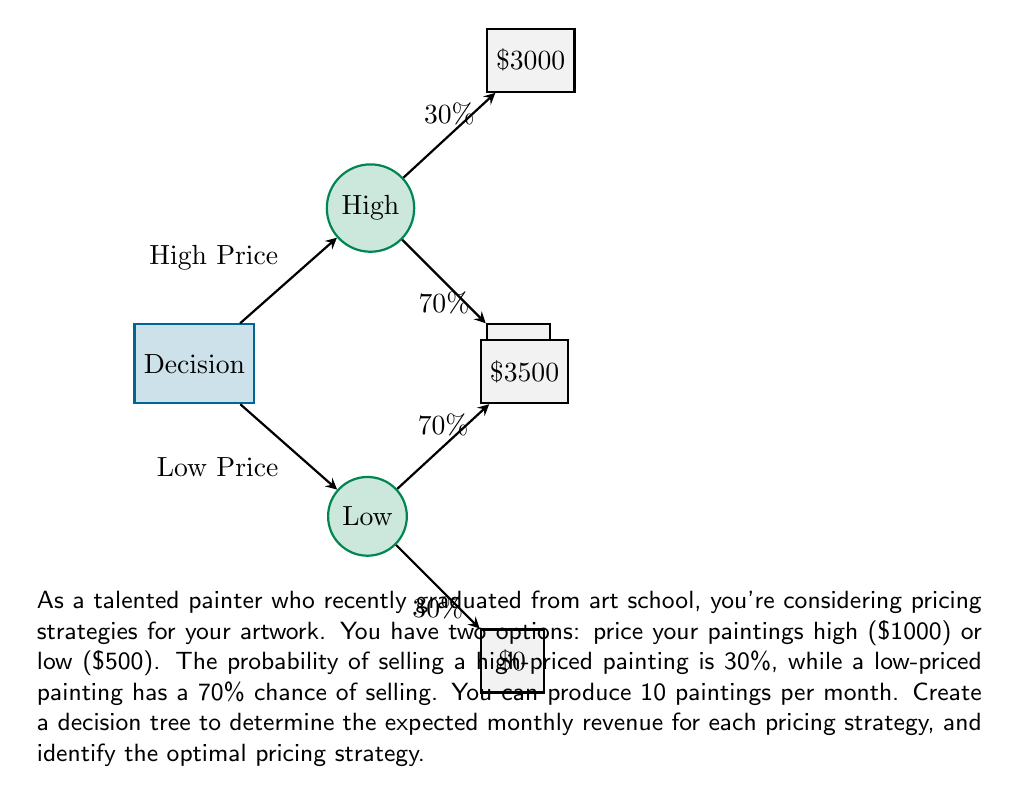Show me your answer to this math problem. Let's solve this problem step by step:

1) First, let's calculate the expected revenue for the high-price strategy:

   Probability of selling = 30% = 0.3
   Revenue if sold = $1000 × 10 paintings = $10,000
   Expected revenue = $10,000 × 0.3 = $3,000

2) Now, let's calculate the expected revenue for the low-price strategy:

   Probability of selling = 70% = 0.7
   Revenue if sold = $500 × 10 paintings = $5,000
   Expected revenue = $5,000 × 0.7 = $3,500

3) We can represent this in a decision tree:

   $$
   \begin{array}{l}
   \text{High Price} \begin{cases}
   30\%: \$3000 \\
   70\%: \$0
   \end{cases} \\
   \text{Low Price} \begin{cases}
   70\%: \$3500 \\
   30\%: \$0
   \end{cases}
   \end{array}
   $$

4) To determine the optimal strategy, we compare the expected revenues:

   High-price strategy: $3,000
   Low-price strategy: $3,500

5) The low-price strategy yields a higher expected revenue.

Therefore, the optimal pricing strategy is to price the paintings low at $500 each.
Answer: Low-price strategy ($500 per painting) 